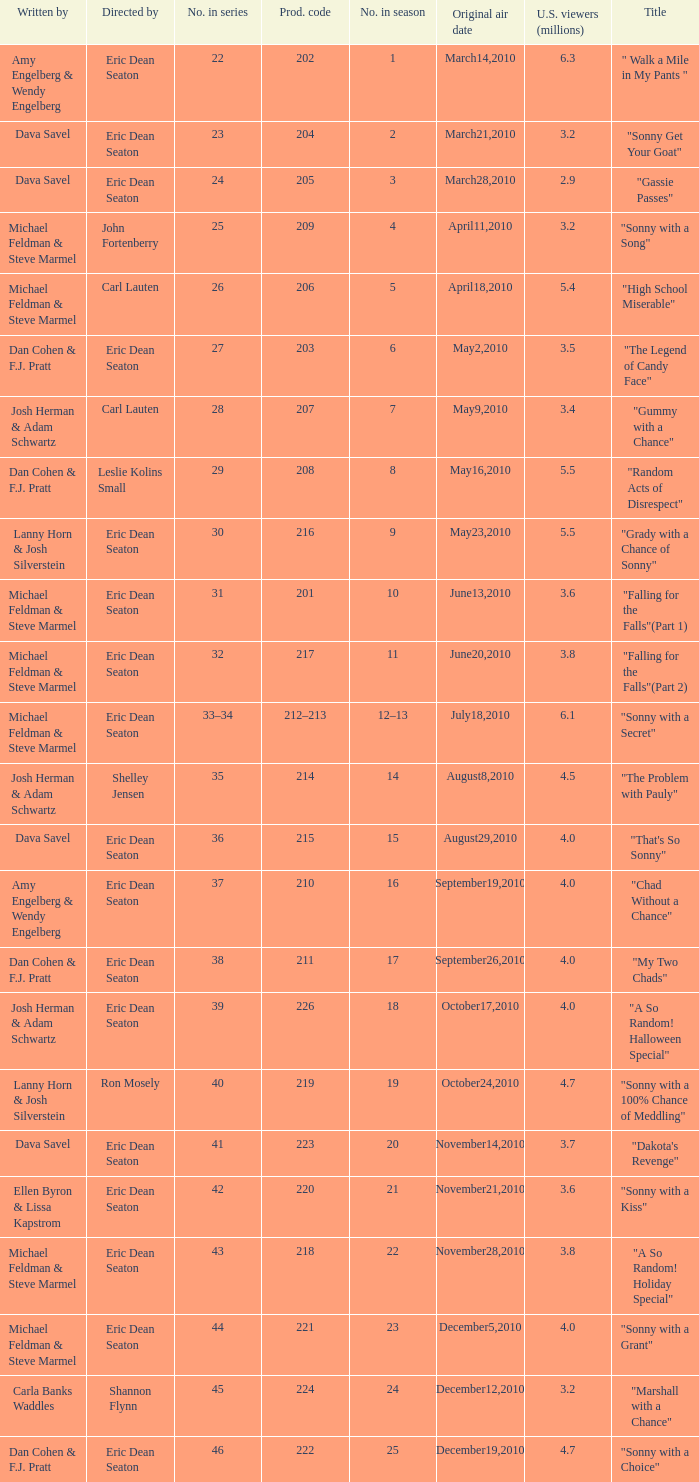Who directed the episode that 6.3 million u.s. viewers saw? Eric Dean Seaton. 